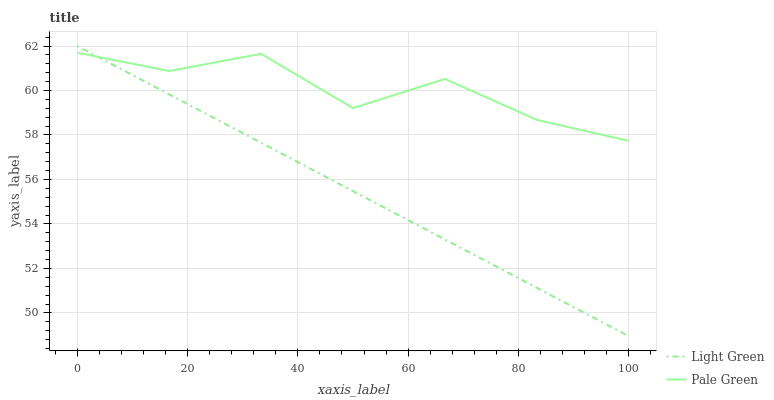Does Light Green have the minimum area under the curve?
Answer yes or no. Yes. Does Pale Green have the maximum area under the curve?
Answer yes or no. Yes. Does Light Green have the maximum area under the curve?
Answer yes or no. No. Is Light Green the smoothest?
Answer yes or no. Yes. Is Pale Green the roughest?
Answer yes or no. Yes. Is Light Green the roughest?
Answer yes or no. No. Does Light Green have the lowest value?
Answer yes or no. Yes. Does Light Green have the highest value?
Answer yes or no. Yes. Does Pale Green intersect Light Green?
Answer yes or no. Yes. Is Pale Green less than Light Green?
Answer yes or no. No. Is Pale Green greater than Light Green?
Answer yes or no. No. 